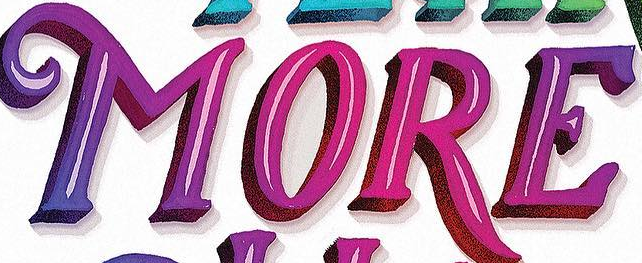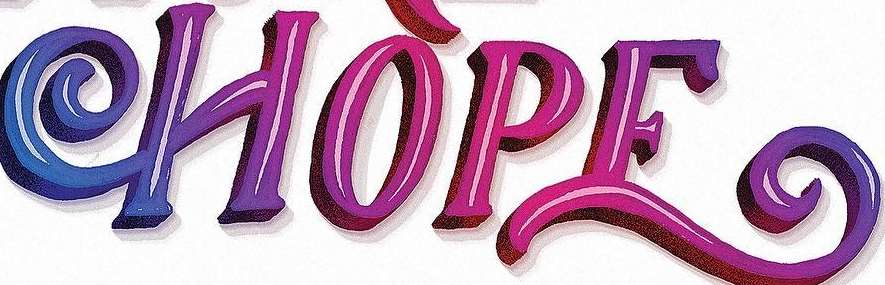Read the text from these images in sequence, separated by a semicolon. MORE; HOPE 